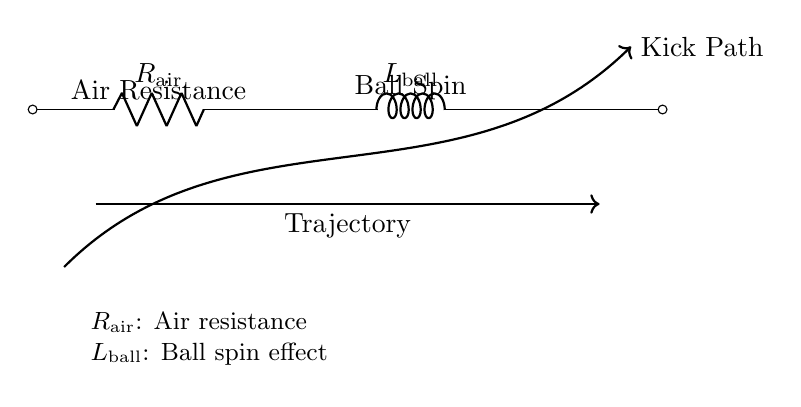What is the resistor labeled as in the circuit? The resistor in the diagram is labeled as R_air, indicating it represents air resistance acting on the ball during its flight.
Answer: R_air What does the inductor represent in the circuit? The inductor is labeled as L_ball, which indicates that it represents the effect of the ball’s spin on its trajectory during flight.
Answer: L_ball What direction does the trajectory of the kick path indicate? The arrow representing the kick path points from the left to the right, indicating the direction in which the ball will travel after being kicked.
Answer: Right How many components are in the circuit? There are two components visible: one resistor and one inductor. Counting both components gives a total of two.
Answer: Two Explain how air resistance affects the football's trajectory. Air resistance, represented by R_air, opposes the motion of the ball as it travels through the air. This resistance slows the ball down, affecting its range and height, making it crucial for developing kicking techniques.
Answer: Opposes motion What two factors are indicated as influencing the football's flight in the circuit? The diagram highlights air resistance (R_air) and ball spin (L_ball) as the two factors influencing the trajectory of the football during its flight.
Answer: Air resistance and ball spin 